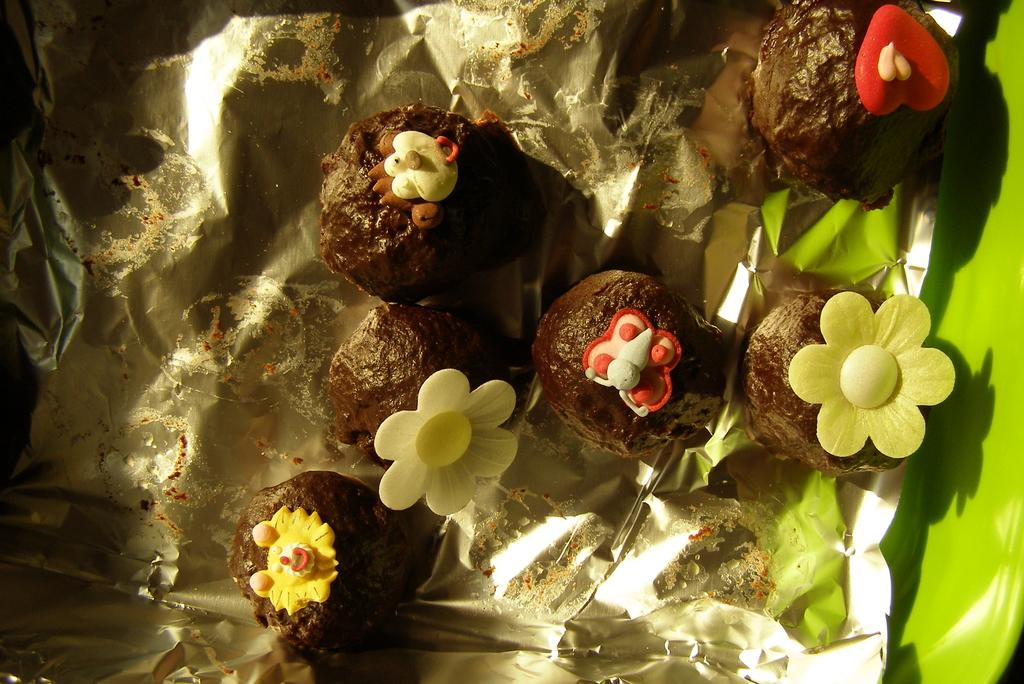What is the main subject of the image? There is a food item in the image. How is the food item wrapped or covered? The food item is kept on aluminium paper. Where is the food item located in the image? The food item is located in the middle of the image. How many basketballs can be seen in the image? There are no basketballs present in the image. What is the mind's role in the image? The image does not depict or involve any mental processes or thoughts, so the mind's role cannot be determined. 